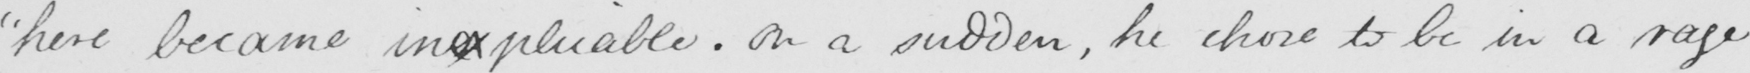Transcribe the text shown in this historical manuscript line. " here became inexplicable . On a sudden , he chose to be in a rage 